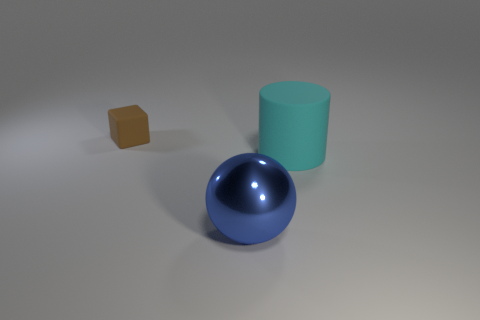What size is the cylinder that is the same material as the tiny object?
Make the answer very short. Large. Is the size of the cyan matte cylinder the same as the thing that is to the left of the blue ball?
Your answer should be very brief. No. Are there the same number of tiny brown matte objects in front of the big blue object and green matte cylinders?
Your answer should be very brief. Yes. Are there any other things that are made of the same material as the blue object?
Make the answer very short. No. There is a metallic thing; does it have the same color as the rubber object that is in front of the tiny matte cube?
Your answer should be very brief. No. Are there any blue metal things that are behind the tiny object left of the object that is on the right side of the shiny sphere?
Make the answer very short. No. Are there fewer tiny objects to the right of the large sphere than small objects?
Your answer should be compact. Yes. What number of other objects are the same shape as the large matte thing?
Offer a terse response. 0. What number of things are either rubber things that are in front of the tiny brown rubber cube or tiny brown blocks to the left of the big blue metal object?
Offer a terse response. 2. There is a object that is on the left side of the large rubber cylinder and in front of the brown rubber block; how big is it?
Your answer should be very brief. Large. 